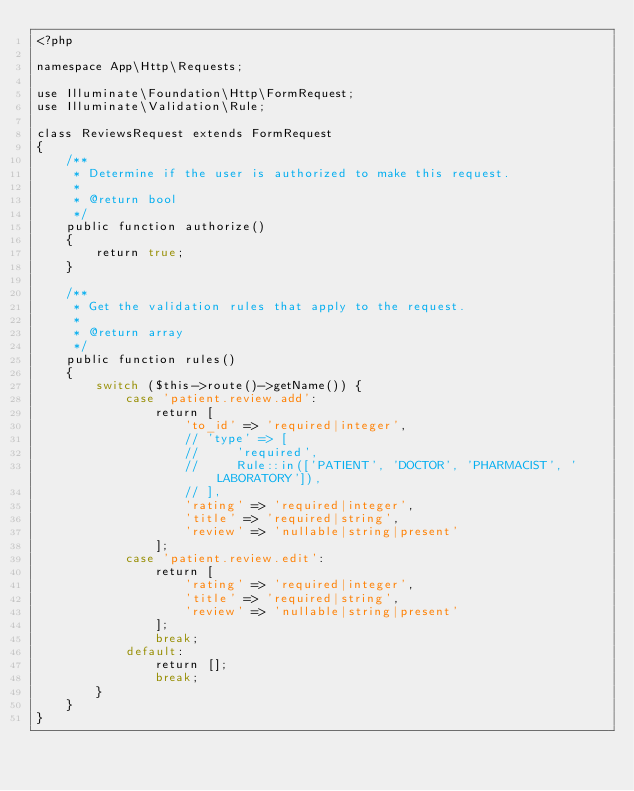Convert code to text. <code><loc_0><loc_0><loc_500><loc_500><_PHP_><?php

namespace App\Http\Requests;

use Illuminate\Foundation\Http\FormRequest;
use Illuminate\Validation\Rule;

class ReviewsRequest extends FormRequest
{
    /**
     * Determine if the user is authorized to make this request.
     *
     * @return bool
     */
    public function authorize()
    {
        return true;
    }

    /**
     * Get the validation rules that apply to the request.
     *
     * @return array
     */
    public function rules()
    {
        switch ($this->route()->getName()) {
            case 'patient.review.add':
                return [
                    'to_id' => 'required|integer',
                    // 'type' => [
                    //     'required',
                    //     Rule::in(['PATIENT', 'DOCTOR', 'PHARMACIST', 'LABORATORY']),
                    // ],
                    'rating' => 'required|integer',
                    'title' => 'required|string',
                    'review' => 'nullable|string|present'
                ];
            case 'patient.review.edit':
                return [
                    'rating' => 'required|integer',
                    'title' => 'required|string',
                    'review' => 'nullable|string|present'
                ];
                break;
            default:
                return [];
                break;
        }
    }
}
</code> 